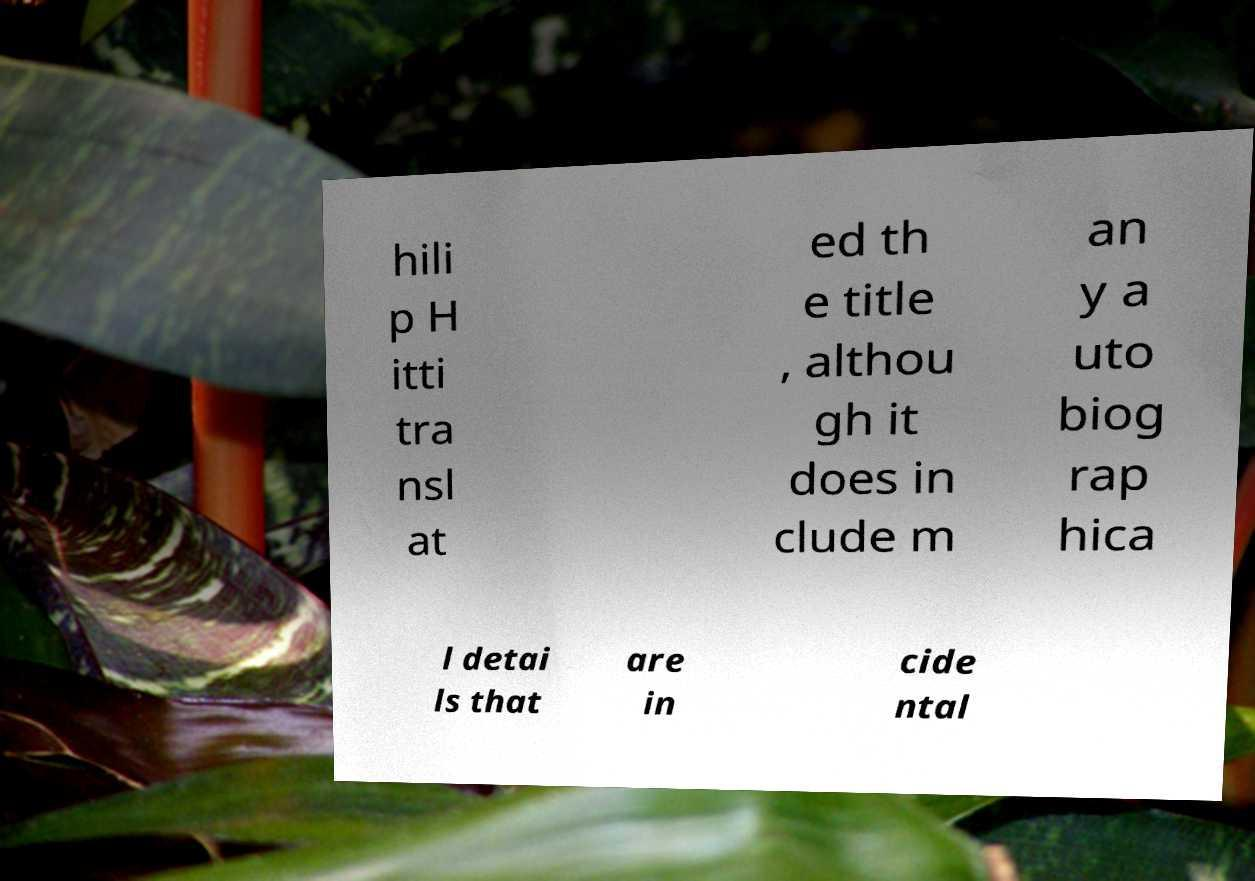Could you extract and type out the text from this image? hili p H itti tra nsl at ed th e title , althou gh it does in clude m an y a uto biog rap hica l detai ls that are in cide ntal 